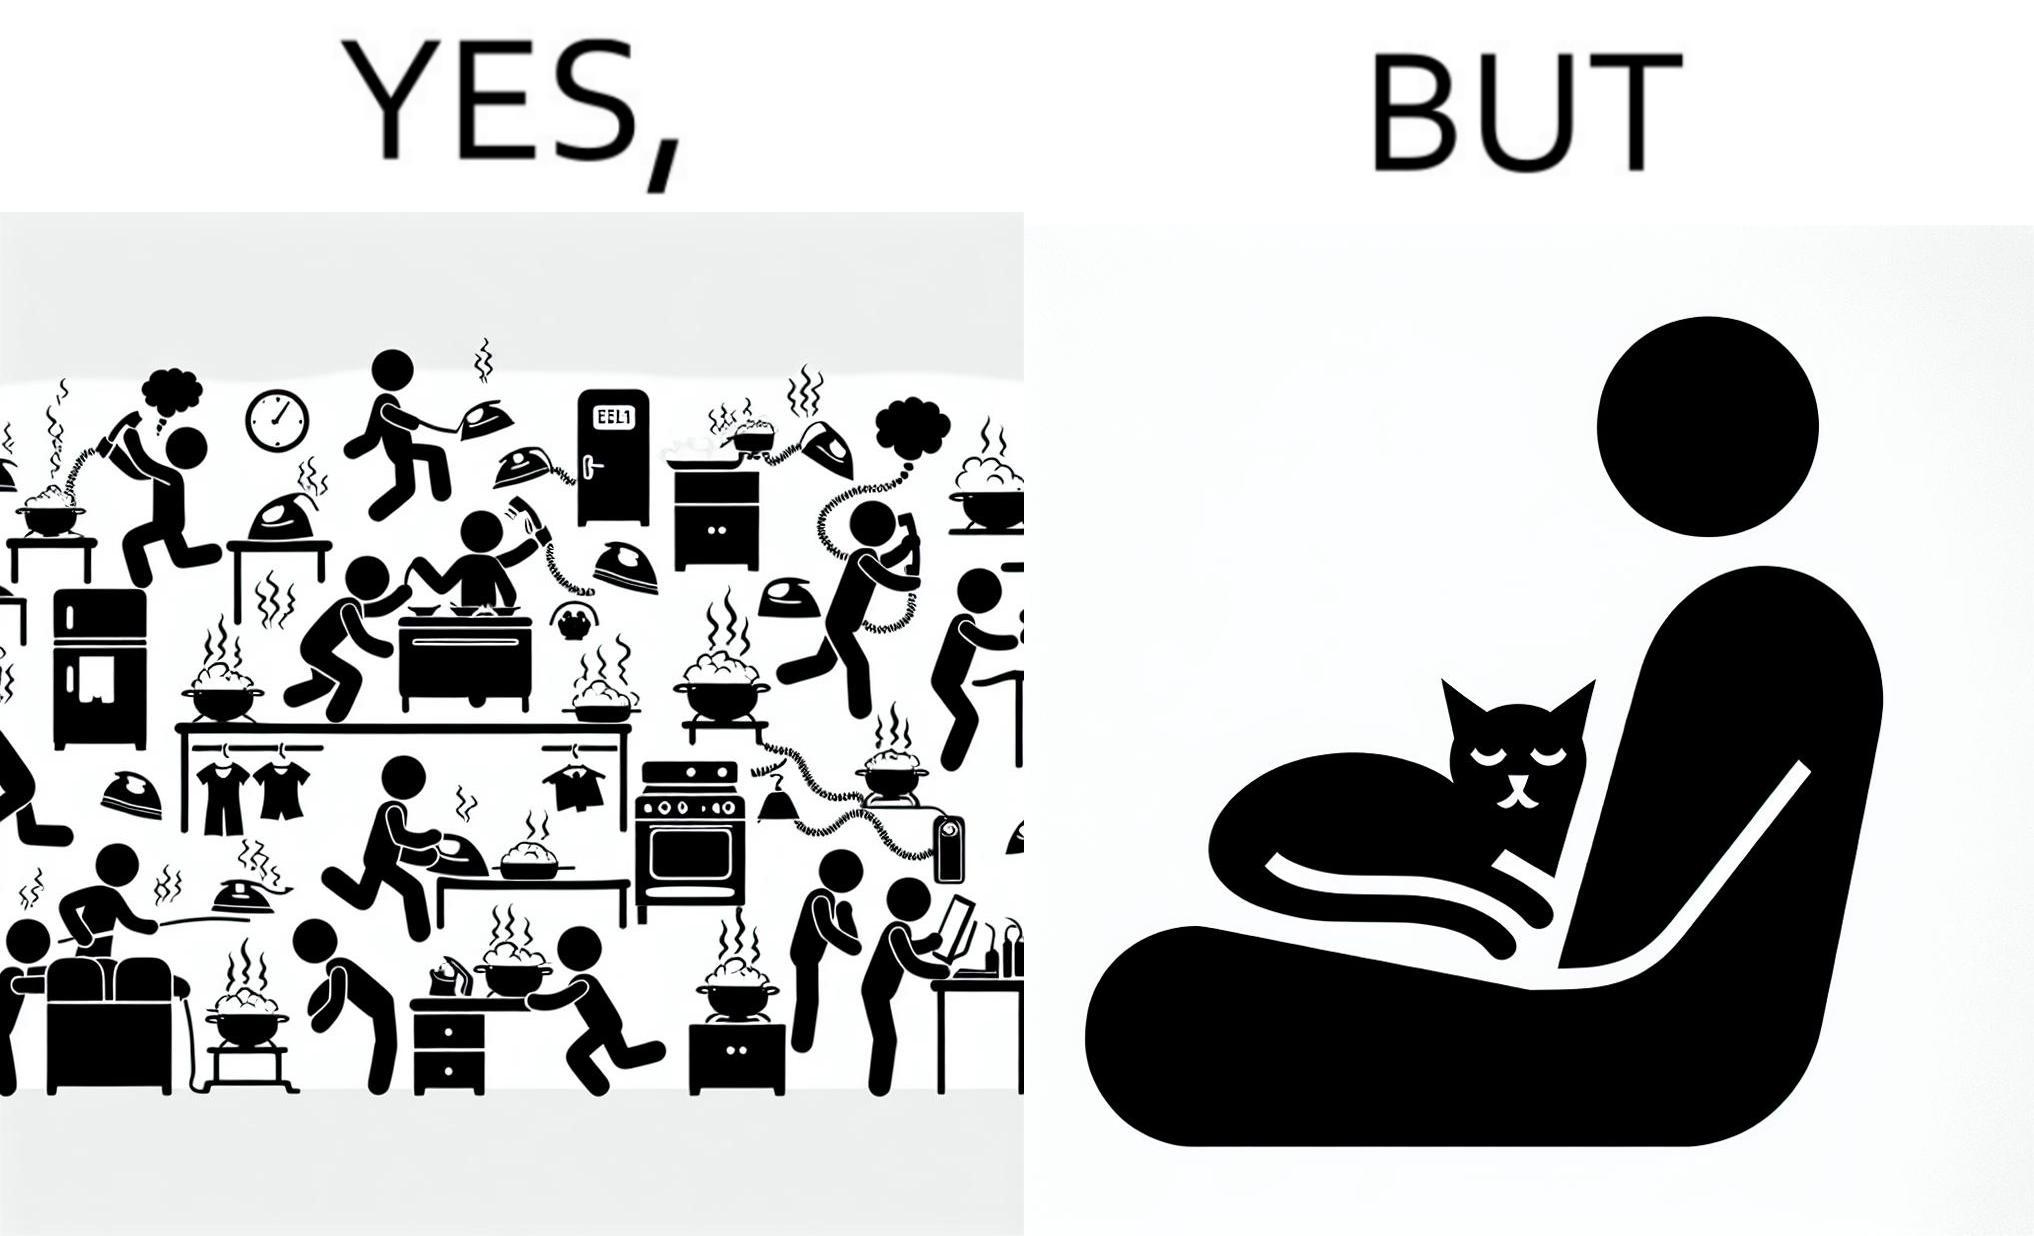Compare the left and right sides of this image. In the left part of the image: Image depicts chaos in a household with overflowing pots, ringing phone, door bell going off, and the iron burning clothes In the right part of the image: a cat sleeping on the lap of a person 